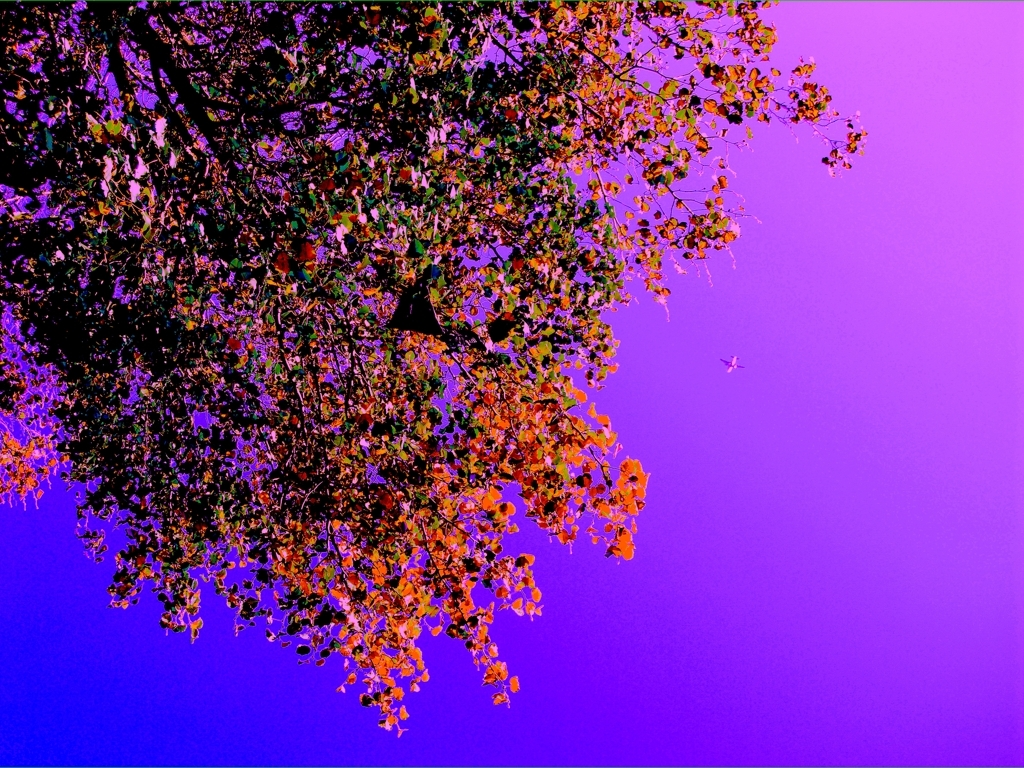What mood does this image evoke? The image evokes a sense of mystery and calm, with the deep purples and contrasting tree silhouette creating a serene and somewhat surreal atmosphere. It may also stimulate the imagination, inspiring thoughts of fantasy landscapes. 